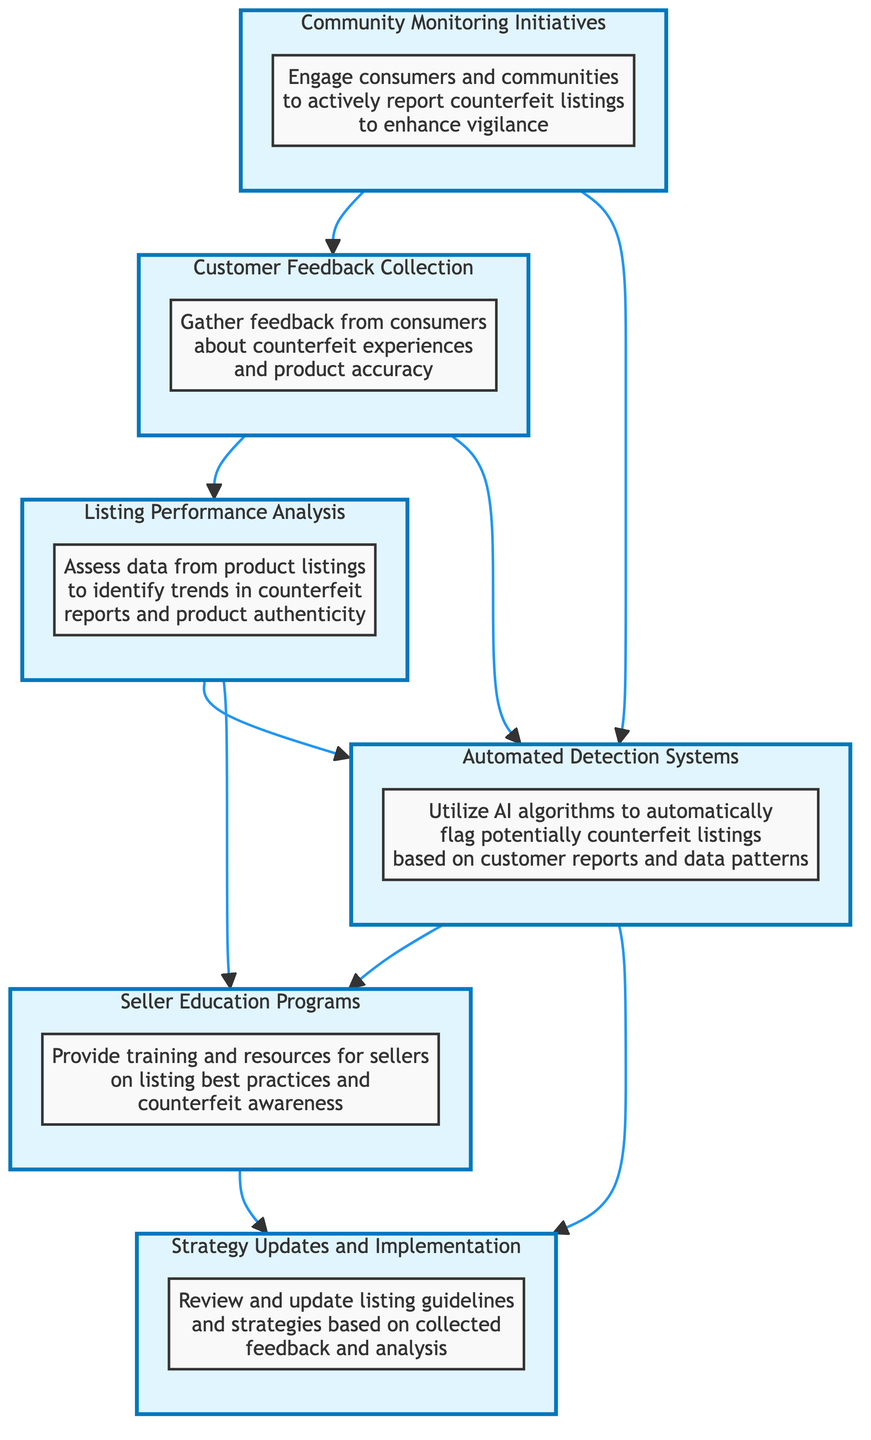What is the first step in the feedback loop? The first step is labeled "Customer Feedback Collection," which is at the bottom of the flow diagram and collects feedback from consumers. Therefore, it indicates the starting point of the feedback loop.
Answer: Customer Feedback Collection How many main elements are there in the diagram? The elements are six in total: Customer Feedback Collection, Listing Performance Analysis, Automated Detection Systems, Seller Education Programs, Strategy Updates and Implementation, and Community Monitoring Initiatives. Therefore, the count of these elements is the answer.
Answer: Six What is the role of Community Monitoring Initiatives? The role of Community Monitoring Initiatives is to engage consumers and communities to actively report counterfeit listings. This relationship shows its function in the feedback loop.
Answer: Engage consumers and communities Which element assesses trends in counterfeit reports? The element that assesses trends in counterfeit reports is "Listing Performance Analysis." This node is responsible for evaluating the data and identifying patterns related to counterfeit issues.
Answer: Listing Performance Analysis What connects Customer Feedback Collection to Automated Detection Systems? The connection is made through a direct flow from "Customer Feedback Collection" to "Automated Detection Systems." This indicates that feedback from consumers is used to feed into the detection systems for counterfeit listings.
Answer: Direct flow How do Automated Detection Systems interact with Seller Education Programs? Automated Detection Systems interact with Seller Education Programs by first analyzing data to flag counterfeit items, and the findings lead to education on best practices for sellers. The relationships in the diagram clarify this sequence.
Answer: Through analysis and findings Which elements involve the community? The elements that involve the community are "Community Monitoring Initiatives" and "Customer Feedback Collection." The flow diagram indicates that these elements engage consumers and collect their insights regarding listings.
Answer: Community Monitoring Initiatives, Customer Feedback Collection What is the endpoint of the feedback loop? The endpoint of the feedback loop ultimately leads to "Strategy Updates and Implementation," as it signifies the outcome of all previous analyses and actions taken from the feedback collected.
Answer: Strategy Updates and Implementation 